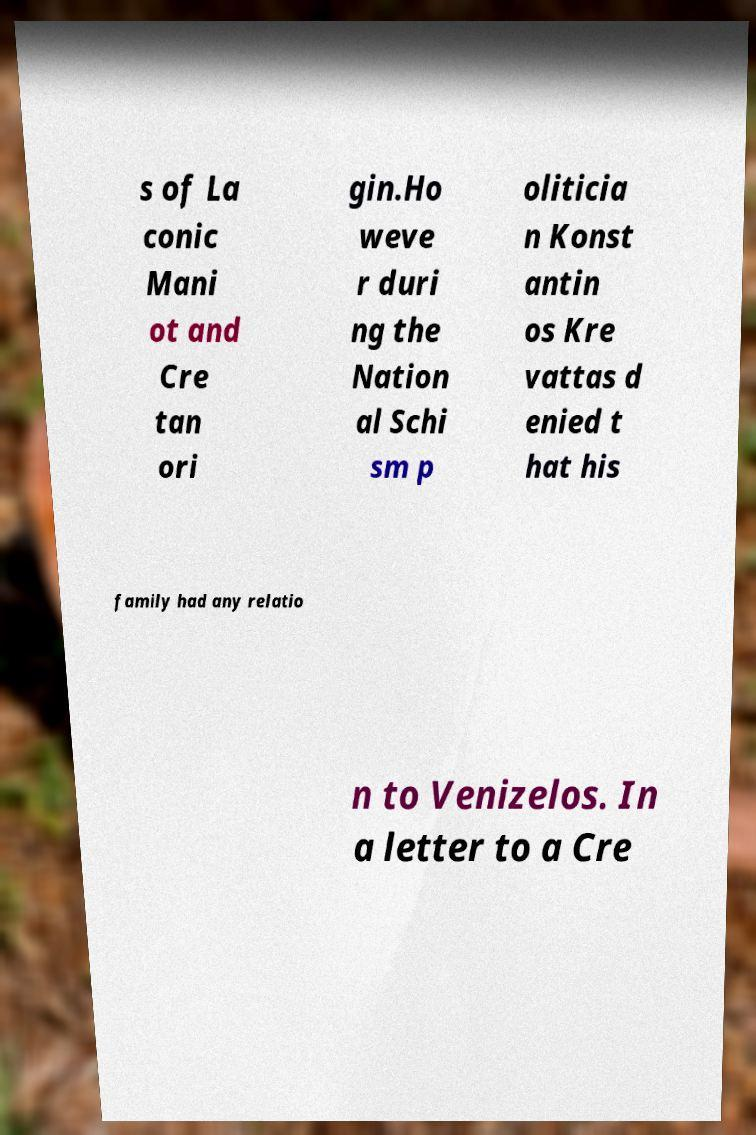Could you extract and type out the text from this image? s of La conic Mani ot and Cre tan ori gin.Ho weve r duri ng the Nation al Schi sm p oliticia n Konst antin os Kre vattas d enied t hat his family had any relatio n to Venizelos. In a letter to a Cre 